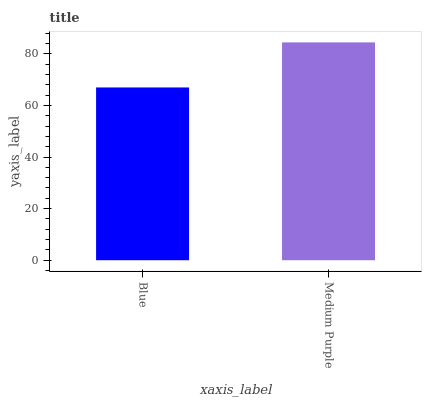Is Blue the minimum?
Answer yes or no. Yes. Is Medium Purple the maximum?
Answer yes or no. Yes. Is Medium Purple the minimum?
Answer yes or no. No. Is Medium Purple greater than Blue?
Answer yes or no. Yes. Is Blue less than Medium Purple?
Answer yes or no. Yes. Is Blue greater than Medium Purple?
Answer yes or no. No. Is Medium Purple less than Blue?
Answer yes or no. No. Is Medium Purple the high median?
Answer yes or no. Yes. Is Blue the low median?
Answer yes or no. Yes. Is Blue the high median?
Answer yes or no. No. Is Medium Purple the low median?
Answer yes or no. No. 